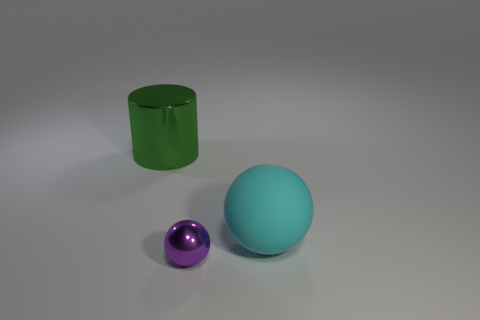Subtract all gray spheres. Subtract all cyan cylinders. How many spheres are left? 2 Add 2 big red matte balls. How many objects exist? 5 Subtract all spheres. How many objects are left? 1 Add 2 big matte spheres. How many big matte spheres exist? 3 Subtract 0 blue cylinders. How many objects are left? 3 Subtract all gray metal cylinders. Subtract all big spheres. How many objects are left? 2 Add 2 tiny purple metal balls. How many tiny purple metal balls are left? 3 